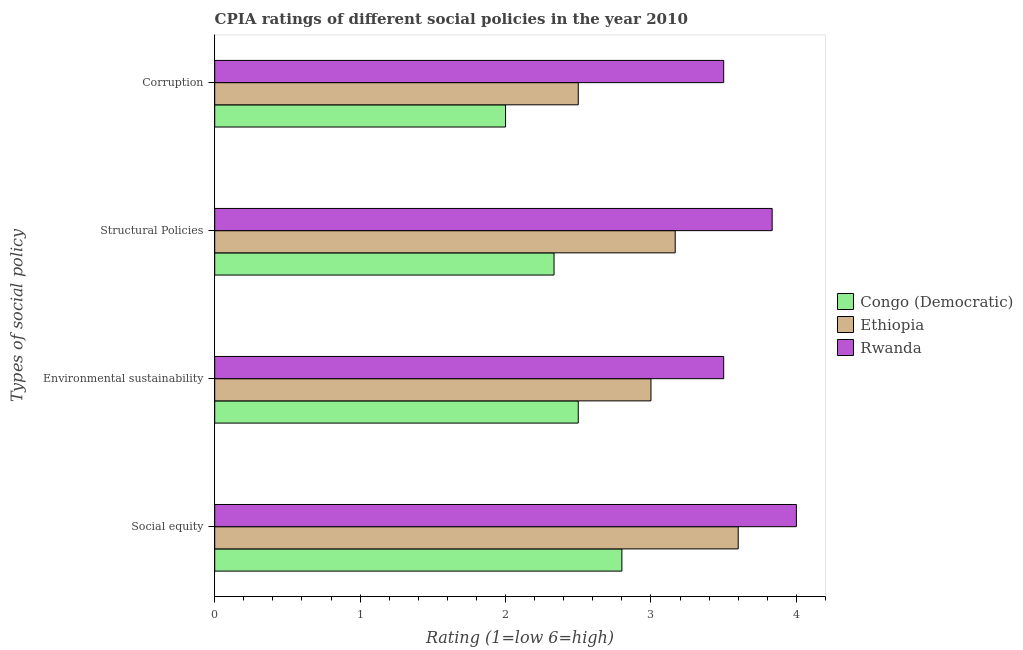Are the number of bars per tick equal to the number of legend labels?
Your response must be concise. Yes. What is the label of the 2nd group of bars from the top?
Your response must be concise. Structural Policies. What is the cpia rating of structural policies in Ethiopia?
Offer a very short reply. 3.17. Across all countries, what is the minimum cpia rating of environmental sustainability?
Ensure brevity in your answer.  2.5. In which country was the cpia rating of structural policies maximum?
Ensure brevity in your answer.  Rwanda. In which country was the cpia rating of structural policies minimum?
Give a very brief answer. Congo (Democratic). What is the difference between the cpia rating of structural policies in Rwanda and that in Congo (Democratic)?
Ensure brevity in your answer.  1.5. What is the difference between the cpia rating of corruption in Rwanda and the cpia rating of social equity in Ethiopia?
Your response must be concise. -0.1. What is the average cpia rating of environmental sustainability per country?
Your answer should be very brief. 3. What is the difference between the cpia rating of social equity and cpia rating of structural policies in Rwanda?
Ensure brevity in your answer.  0.17. In how many countries, is the cpia rating of structural policies greater than 4 ?
Offer a very short reply. 0. What is the ratio of the cpia rating of structural policies in Congo (Democratic) to that in Rwanda?
Provide a succinct answer. 0.61. What is the difference between the highest and the lowest cpia rating of social equity?
Make the answer very short. 1.2. In how many countries, is the cpia rating of social equity greater than the average cpia rating of social equity taken over all countries?
Your answer should be very brief. 2. What does the 1st bar from the top in Social equity represents?
Your answer should be very brief. Rwanda. What does the 2nd bar from the bottom in Social equity represents?
Make the answer very short. Ethiopia. How many bars are there?
Make the answer very short. 12. What is the difference between two consecutive major ticks on the X-axis?
Offer a very short reply. 1. Are the values on the major ticks of X-axis written in scientific E-notation?
Your answer should be very brief. No. Does the graph contain any zero values?
Give a very brief answer. No. Does the graph contain grids?
Give a very brief answer. No. How many legend labels are there?
Your response must be concise. 3. How are the legend labels stacked?
Offer a terse response. Vertical. What is the title of the graph?
Provide a short and direct response. CPIA ratings of different social policies in the year 2010. What is the label or title of the X-axis?
Your answer should be very brief. Rating (1=low 6=high). What is the label or title of the Y-axis?
Make the answer very short. Types of social policy. What is the Rating (1=low 6=high) of Congo (Democratic) in Social equity?
Your answer should be compact. 2.8. What is the Rating (1=low 6=high) in Ethiopia in Social equity?
Your answer should be very brief. 3.6. What is the Rating (1=low 6=high) of Congo (Democratic) in Environmental sustainability?
Offer a very short reply. 2.5. What is the Rating (1=low 6=high) in Congo (Democratic) in Structural Policies?
Ensure brevity in your answer.  2.33. What is the Rating (1=low 6=high) of Ethiopia in Structural Policies?
Offer a very short reply. 3.17. What is the Rating (1=low 6=high) of Rwanda in Structural Policies?
Offer a terse response. 3.83. What is the Rating (1=low 6=high) of Congo (Democratic) in Corruption?
Your answer should be compact. 2. What is the Rating (1=low 6=high) of Ethiopia in Corruption?
Provide a succinct answer. 2.5. Across all Types of social policy, what is the maximum Rating (1=low 6=high) of Congo (Democratic)?
Provide a short and direct response. 2.8. Across all Types of social policy, what is the maximum Rating (1=low 6=high) of Ethiopia?
Offer a terse response. 3.6. Across all Types of social policy, what is the minimum Rating (1=low 6=high) in Congo (Democratic)?
Make the answer very short. 2. Across all Types of social policy, what is the minimum Rating (1=low 6=high) of Ethiopia?
Offer a terse response. 2.5. Across all Types of social policy, what is the minimum Rating (1=low 6=high) in Rwanda?
Ensure brevity in your answer.  3.5. What is the total Rating (1=low 6=high) of Congo (Democratic) in the graph?
Offer a terse response. 9.63. What is the total Rating (1=low 6=high) in Ethiopia in the graph?
Your answer should be very brief. 12.27. What is the total Rating (1=low 6=high) of Rwanda in the graph?
Offer a terse response. 14.83. What is the difference between the Rating (1=low 6=high) in Congo (Democratic) in Social equity and that in Environmental sustainability?
Your answer should be compact. 0.3. What is the difference between the Rating (1=low 6=high) in Ethiopia in Social equity and that in Environmental sustainability?
Give a very brief answer. 0.6. What is the difference between the Rating (1=low 6=high) of Rwanda in Social equity and that in Environmental sustainability?
Offer a very short reply. 0.5. What is the difference between the Rating (1=low 6=high) of Congo (Democratic) in Social equity and that in Structural Policies?
Make the answer very short. 0.47. What is the difference between the Rating (1=low 6=high) in Ethiopia in Social equity and that in Structural Policies?
Your response must be concise. 0.43. What is the difference between the Rating (1=low 6=high) in Ethiopia in Social equity and that in Corruption?
Provide a succinct answer. 1.1. What is the difference between the Rating (1=low 6=high) of Rwanda in Social equity and that in Corruption?
Provide a succinct answer. 0.5. What is the difference between the Rating (1=low 6=high) in Congo (Democratic) in Environmental sustainability and that in Structural Policies?
Offer a terse response. 0.17. What is the difference between the Rating (1=low 6=high) of Ethiopia in Environmental sustainability and that in Structural Policies?
Your response must be concise. -0.17. What is the difference between the Rating (1=low 6=high) of Ethiopia in Environmental sustainability and that in Corruption?
Your answer should be very brief. 0.5. What is the difference between the Rating (1=low 6=high) in Ethiopia in Structural Policies and that in Corruption?
Keep it short and to the point. 0.67. What is the difference between the Rating (1=low 6=high) of Rwanda in Structural Policies and that in Corruption?
Make the answer very short. 0.33. What is the difference between the Rating (1=low 6=high) of Congo (Democratic) in Social equity and the Rating (1=low 6=high) of Rwanda in Environmental sustainability?
Make the answer very short. -0.7. What is the difference between the Rating (1=low 6=high) of Ethiopia in Social equity and the Rating (1=low 6=high) of Rwanda in Environmental sustainability?
Your response must be concise. 0.1. What is the difference between the Rating (1=low 6=high) of Congo (Democratic) in Social equity and the Rating (1=low 6=high) of Ethiopia in Structural Policies?
Your response must be concise. -0.37. What is the difference between the Rating (1=low 6=high) of Congo (Democratic) in Social equity and the Rating (1=low 6=high) of Rwanda in Structural Policies?
Make the answer very short. -1.03. What is the difference between the Rating (1=low 6=high) in Ethiopia in Social equity and the Rating (1=low 6=high) in Rwanda in Structural Policies?
Your response must be concise. -0.23. What is the difference between the Rating (1=low 6=high) in Ethiopia in Social equity and the Rating (1=low 6=high) in Rwanda in Corruption?
Your answer should be compact. 0.1. What is the difference between the Rating (1=low 6=high) in Congo (Democratic) in Environmental sustainability and the Rating (1=low 6=high) in Ethiopia in Structural Policies?
Offer a very short reply. -0.67. What is the difference between the Rating (1=low 6=high) in Congo (Democratic) in Environmental sustainability and the Rating (1=low 6=high) in Rwanda in Structural Policies?
Ensure brevity in your answer.  -1.33. What is the difference between the Rating (1=low 6=high) of Ethiopia in Environmental sustainability and the Rating (1=low 6=high) of Rwanda in Structural Policies?
Ensure brevity in your answer.  -0.83. What is the difference between the Rating (1=low 6=high) of Congo (Democratic) in Environmental sustainability and the Rating (1=low 6=high) of Ethiopia in Corruption?
Provide a succinct answer. 0. What is the difference between the Rating (1=low 6=high) in Congo (Democratic) in Structural Policies and the Rating (1=low 6=high) in Ethiopia in Corruption?
Ensure brevity in your answer.  -0.17. What is the difference between the Rating (1=low 6=high) of Congo (Democratic) in Structural Policies and the Rating (1=low 6=high) of Rwanda in Corruption?
Your response must be concise. -1.17. What is the difference between the Rating (1=low 6=high) of Ethiopia in Structural Policies and the Rating (1=low 6=high) of Rwanda in Corruption?
Give a very brief answer. -0.33. What is the average Rating (1=low 6=high) of Congo (Democratic) per Types of social policy?
Your answer should be very brief. 2.41. What is the average Rating (1=low 6=high) of Ethiopia per Types of social policy?
Offer a terse response. 3.07. What is the average Rating (1=low 6=high) in Rwanda per Types of social policy?
Make the answer very short. 3.71. What is the difference between the Rating (1=low 6=high) of Congo (Democratic) and Rating (1=low 6=high) of Ethiopia in Social equity?
Provide a succinct answer. -0.8. What is the difference between the Rating (1=low 6=high) in Congo (Democratic) and Rating (1=low 6=high) in Rwanda in Social equity?
Make the answer very short. -1.2. What is the difference between the Rating (1=low 6=high) of Congo (Democratic) and Rating (1=low 6=high) of Ethiopia in Environmental sustainability?
Provide a succinct answer. -0.5. What is the difference between the Rating (1=low 6=high) of Ethiopia and Rating (1=low 6=high) of Rwanda in Environmental sustainability?
Your answer should be compact. -0.5. What is the difference between the Rating (1=low 6=high) in Congo (Democratic) and Rating (1=low 6=high) in Ethiopia in Structural Policies?
Give a very brief answer. -0.83. What is the difference between the Rating (1=low 6=high) of Congo (Democratic) and Rating (1=low 6=high) of Rwanda in Structural Policies?
Offer a terse response. -1.5. What is the difference between the Rating (1=low 6=high) in Ethiopia and Rating (1=low 6=high) in Rwanda in Structural Policies?
Your answer should be compact. -0.67. What is the difference between the Rating (1=low 6=high) of Congo (Democratic) and Rating (1=low 6=high) of Ethiopia in Corruption?
Your response must be concise. -0.5. What is the ratio of the Rating (1=low 6=high) in Congo (Democratic) in Social equity to that in Environmental sustainability?
Provide a short and direct response. 1.12. What is the ratio of the Rating (1=low 6=high) of Ethiopia in Social equity to that in Structural Policies?
Your response must be concise. 1.14. What is the ratio of the Rating (1=low 6=high) of Rwanda in Social equity to that in Structural Policies?
Your answer should be very brief. 1.04. What is the ratio of the Rating (1=low 6=high) of Congo (Democratic) in Social equity to that in Corruption?
Your answer should be compact. 1.4. What is the ratio of the Rating (1=low 6=high) of Ethiopia in Social equity to that in Corruption?
Your response must be concise. 1.44. What is the ratio of the Rating (1=low 6=high) of Congo (Democratic) in Environmental sustainability to that in Structural Policies?
Keep it short and to the point. 1.07. What is the ratio of the Rating (1=low 6=high) of Rwanda in Environmental sustainability to that in Corruption?
Your answer should be compact. 1. What is the ratio of the Rating (1=low 6=high) in Congo (Democratic) in Structural Policies to that in Corruption?
Keep it short and to the point. 1.17. What is the ratio of the Rating (1=low 6=high) in Ethiopia in Structural Policies to that in Corruption?
Offer a very short reply. 1.27. What is the ratio of the Rating (1=low 6=high) of Rwanda in Structural Policies to that in Corruption?
Offer a very short reply. 1.1. What is the difference between the highest and the second highest Rating (1=low 6=high) of Congo (Democratic)?
Your response must be concise. 0.3. What is the difference between the highest and the second highest Rating (1=low 6=high) of Ethiopia?
Keep it short and to the point. 0.43. What is the difference between the highest and the second highest Rating (1=low 6=high) of Rwanda?
Give a very brief answer. 0.17. 